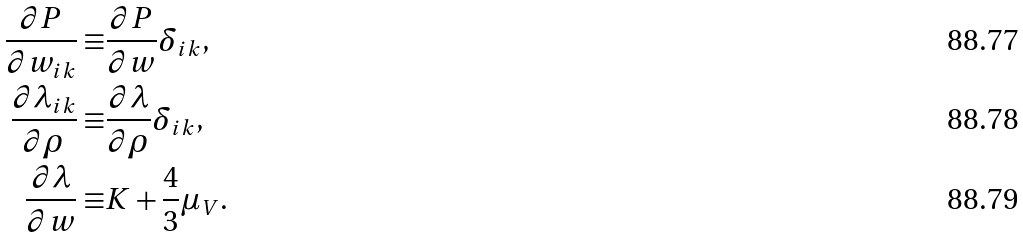Convert formula to latex. <formula><loc_0><loc_0><loc_500><loc_500>\frac { \partial P } { \partial w _ { i k } } \equiv & \frac { \partial P } { \partial w } \delta _ { i k } , \\ \frac { \partial \lambda _ { i k } } { \partial \rho } \equiv & \frac { \partial \lambda } { \partial \rho } \delta _ { i k } , \\ \frac { \partial \lambda } { \partial w } \equiv & K + \frac { 4 } { 3 } \mu _ { V } .</formula> 